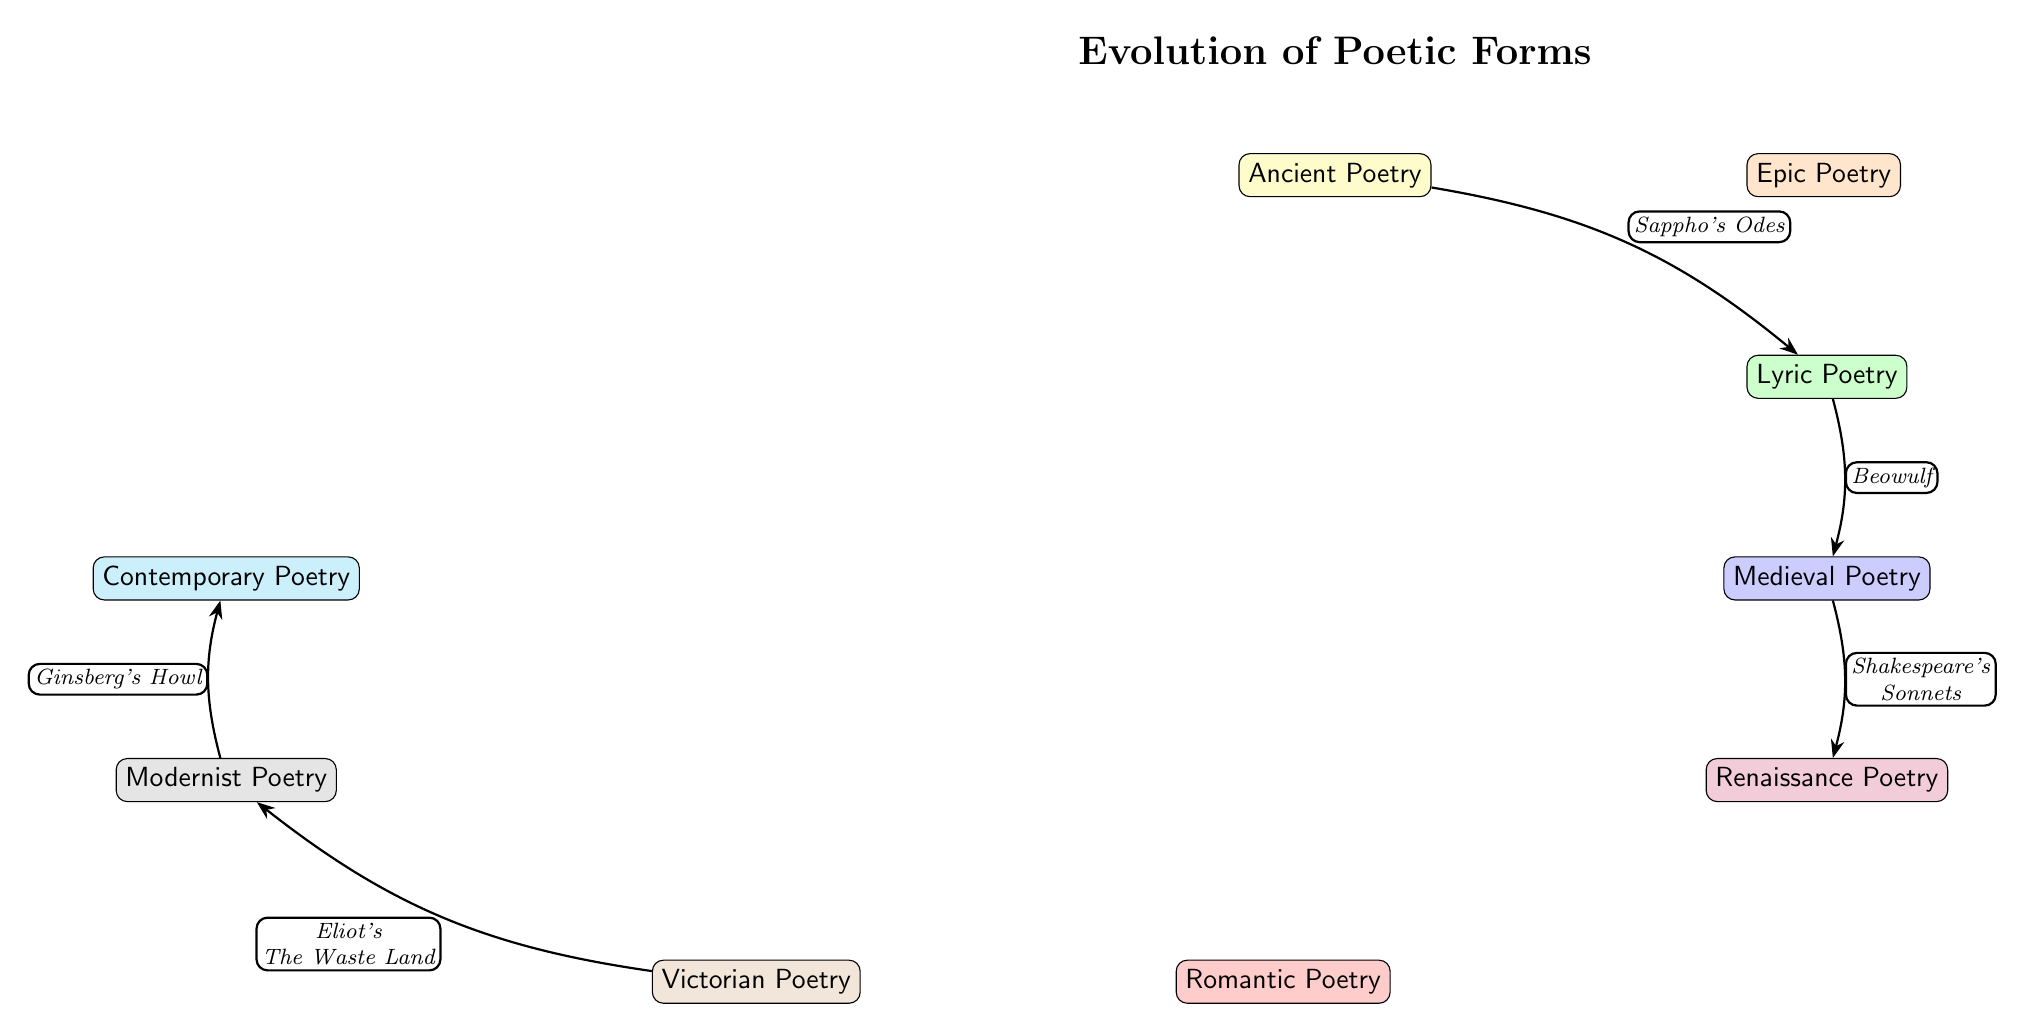What is the first poetic form listed in the diagram? The first node in the diagram is labeled "Ancient Poetry," making it the initial poetic form in the sequence.
Answer: Ancient Poetry Which two notable examples are associated with Epic Poetry? The diagram connects "Ancient Poetry" to "Epic Poetry" with the label "The Iliad, The Odyssey," indicating these are key examples of this poetic form.
Answer: The Iliad, The Odyssey What poetic form follows Lyric Poetry? From the diagram, Lyric Poetry is connected downward to Medieval Poetry, indicating it is the subsequent form in the evolution of poetic styles.
Answer: Medieval Poetry What is the connection between Victorian Poetry and Modernist Poetry? The diagram shows that Victorian Poetry leads to Modernist Poetry through the edge labeled "Eliot's The Waste Land," establishing a direct link between these two forms.
Answer: Eliot's The Waste Land How many poetic forms are illustrated in the diagram? Counting all the unique nodes in the diagram, there are a total of nine poetic forms represented, indicating the scope of poetic evolution covered.
Answer: 9 Which poetic form is considered the starting point for Romantic Poetry? The diagram indicates a direct connection from Renaissance Poetry to Romantic Poetry, suggesting that Renaissance Poetry is the precursor to Romantic styles.
Answer: Renaissance Poetry What is an example of a work from Contemporary Poetry? The diagram concludes with Contemporary Poetry being linked to "Ginsberg's Howl," identifying it as a significant work from this form.
Answer: Ginsberg's Howl Which two poetic forms are most closely related to Epic Poetry in the diagram? Epic Poetry is directly related to both Ancient Poetry and Lyric Poetry, as it is connected to Ancient Poetry above and is in contrast to Lyric Poetry below it.
Answer: Ancient Poetry and Lyric Poetry What is the progression of poetic forms that leads to Contemporary Poetry? The flow from Renaissance Poetry through Romantic Poetry to Victorian Poetry and then to Modernist Poetry shows a progression culminating in Contemporary Poetry, emphasizing the lineage of styles that lead to modern expressions.
Answer: Renaissance Poetry, Romantic Poetry, Victorian Poetry, Modernist Poetry 